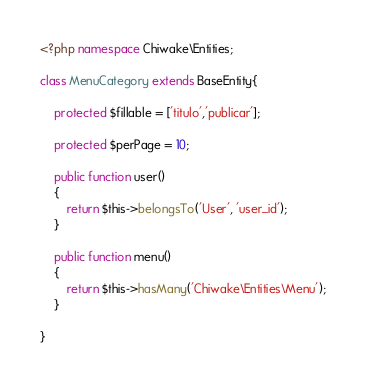<code> <loc_0><loc_0><loc_500><loc_500><_PHP_><?php namespace Chiwake\Entities;

class MenuCategory extends BaseEntity{

    protected $fillable = ['titulo','publicar'];

    protected $perPage = 10;

    public function user()
    {
        return $this->belongsTo('User', 'user_id');
    }

    public function menu()
    {
        return $this->hasMany('Chiwake\Entities\Menu');
    }

} </code> 